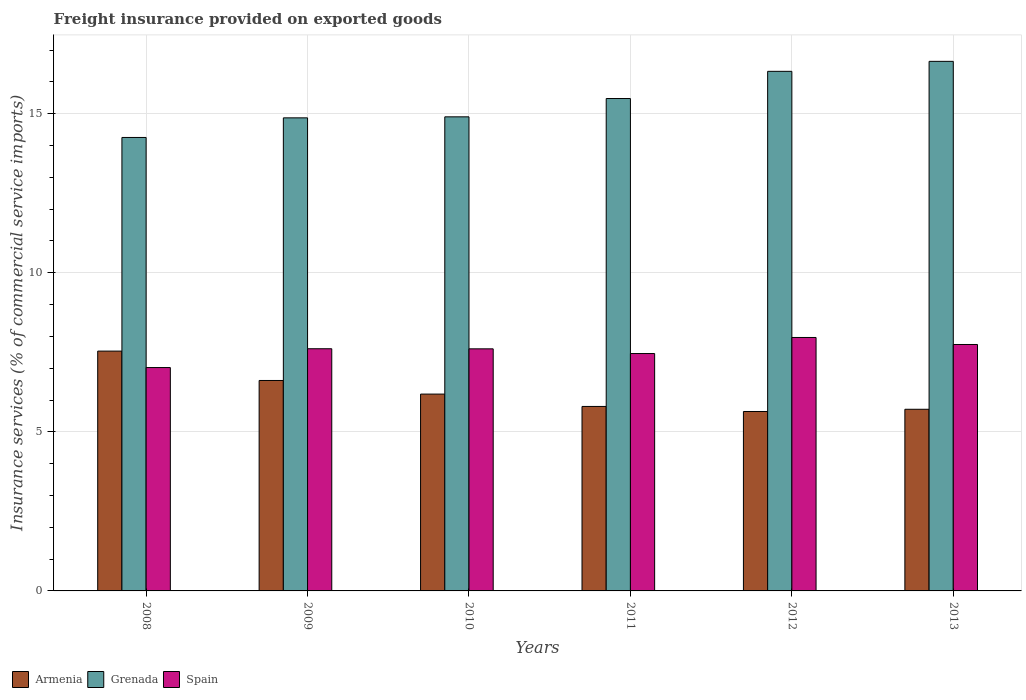How many different coloured bars are there?
Give a very brief answer. 3. Are the number of bars per tick equal to the number of legend labels?
Offer a terse response. Yes. What is the label of the 1st group of bars from the left?
Give a very brief answer. 2008. What is the freight insurance provided on exported goods in Armenia in 2008?
Keep it short and to the point. 7.54. Across all years, what is the maximum freight insurance provided on exported goods in Armenia?
Ensure brevity in your answer.  7.54. Across all years, what is the minimum freight insurance provided on exported goods in Grenada?
Offer a very short reply. 14.25. In which year was the freight insurance provided on exported goods in Spain minimum?
Your answer should be compact. 2008. What is the total freight insurance provided on exported goods in Armenia in the graph?
Offer a very short reply. 37.49. What is the difference between the freight insurance provided on exported goods in Armenia in 2008 and that in 2012?
Provide a short and direct response. 1.9. What is the difference between the freight insurance provided on exported goods in Grenada in 2011 and the freight insurance provided on exported goods in Armenia in 2008?
Your answer should be very brief. 7.94. What is the average freight insurance provided on exported goods in Armenia per year?
Offer a terse response. 6.25. In the year 2011, what is the difference between the freight insurance provided on exported goods in Grenada and freight insurance provided on exported goods in Armenia?
Offer a very short reply. 9.68. In how many years, is the freight insurance provided on exported goods in Armenia greater than 8 %?
Ensure brevity in your answer.  0. What is the ratio of the freight insurance provided on exported goods in Grenada in 2009 to that in 2010?
Provide a short and direct response. 1. Is the freight insurance provided on exported goods in Armenia in 2009 less than that in 2012?
Your response must be concise. No. Is the difference between the freight insurance provided on exported goods in Grenada in 2011 and 2012 greater than the difference between the freight insurance provided on exported goods in Armenia in 2011 and 2012?
Your response must be concise. No. What is the difference between the highest and the second highest freight insurance provided on exported goods in Grenada?
Offer a very short reply. 0.31. What is the difference between the highest and the lowest freight insurance provided on exported goods in Armenia?
Your answer should be very brief. 1.9. In how many years, is the freight insurance provided on exported goods in Spain greater than the average freight insurance provided on exported goods in Spain taken over all years?
Offer a terse response. 4. Is the sum of the freight insurance provided on exported goods in Grenada in 2009 and 2010 greater than the maximum freight insurance provided on exported goods in Armenia across all years?
Offer a terse response. Yes. What does the 2nd bar from the left in 2009 represents?
Give a very brief answer. Grenada. What does the 1st bar from the right in 2012 represents?
Provide a short and direct response. Spain. Are all the bars in the graph horizontal?
Ensure brevity in your answer.  No. What is the difference between two consecutive major ticks on the Y-axis?
Your answer should be compact. 5. Are the values on the major ticks of Y-axis written in scientific E-notation?
Your answer should be very brief. No. Does the graph contain any zero values?
Your answer should be compact. No. Does the graph contain grids?
Offer a terse response. Yes. Where does the legend appear in the graph?
Offer a terse response. Bottom left. How many legend labels are there?
Ensure brevity in your answer.  3. What is the title of the graph?
Make the answer very short. Freight insurance provided on exported goods. Does "Middle East & North Africa (all income levels)" appear as one of the legend labels in the graph?
Ensure brevity in your answer.  No. What is the label or title of the Y-axis?
Your response must be concise. Insurance services (% of commercial service imports). What is the Insurance services (% of commercial service imports) of Armenia in 2008?
Offer a very short reply. 7.54. What is the Insurance services (% of commercial service imports) in Grenada in 2008?
Give a very brief answer. 14.25. What is the Insurance services (% of commercial service imports) in Spain in 2008?
Your response must be concise. 7.02. What is the Insurance services (% of commercial service imports) in Armenia in 2009?
Ensure brevity in your answer.  6.62. What is the Insurance services (% of commercial service imports) in Grenada in 2009?
Your answer should be very brief. 14.87. What is the Insurance services (% of commercial service imports) in Spain in 2009?
Keep it short and to the point. 7.61. What is the Insurance services (% of commercial service imports) of Armenia in 2010?
Offer a very short reply. 6.19. What is the Insurance services (% of commercial service imports) of Grenada in 2010?
Offer a terse response. 14.9. What is the Insurance services (% of commercial service imports) in Spain in 2010?
Ensure brevity in your answer.  7.61. What is the Insurance services (% of commercial service imports) in Armenia in 2011?
Your answer should be compact. 5.8. What is the Insurance services (% of commercial service imports) in Grenada in 2011?
Offer a terse response. 15.48. What is the Insurance services (% of commercial service imports) of Spain in 2011?
Offer a very short reply. 7.46. What is the Insurance services (% of commercial service imports) in Armenia in 2012?
Provide a short and direct response. 5.64. What is the Insurance services (% of commercial service imports) in Grenada in 2012?
Keep it short and to the point. 16.33. What is the Insurance services (% of commercial service imports) of Spain in 2012?
Provide a short and direct response. 7.97. What is the Insurance services (% of commercial service imports) in Armenia in 2013?
Offer a terse response. 5.71. What is the Insurance services (% of commercial service imports) of Grenada in 2013?
Keep it short and to the point. 16.65. What is the Insurance services (% of commercial service imports) in Spain in 2013?
Give a very brief answer. 7.75. Across all years, what is the maximum Insurance services (% of commercial service imports) in Armenia?
Your answer should be very brief. 7.54. Across all years, what is the maximum Insurance services (% of commercial service imports) of Grenada?
Your answer should be very brief. 16.65. Across all years, what is the maximum Insurance services (% of commercial service imports) in Spain?
Give a very brief answer. 7.97. Across all years, what is the minimum Insurance services (% of commercial service imports) in Armenia?
Provide a short and direct response. 5.64. Across all years, what is the minimum Insurance services (% of commercial service imports) of Grenada?
Offer a very short reply. 14.25. Across all years, what is the minimum Insurance services (% of commercial service imports) in Spain?
Your answer should be compact. 7.02. What is the total Insurance services (% of commercial service imports) of Armenia in the graph?
Offer a very short reply. 37.49. What is the total Insurance services (% of commercial service imports) in Grenada in the graph?
Provide a short and direct response. 92.49. What is the total Insurance services (% of commercial service imports) of Spain in the graph?
Give a very brief answer. 45.42. What is the difference between the Insurance services (% of commercial service imports) in Armenia in 2008 and that in 2009?
Make the answer very short. 0.92. What is the difference between the Insurance services (% of commercial service imports) in Grenada in 2008 and that in 2009?
Your answer should be very brief. -0.62. What is the difference between the Insurance services (% of commercial service imports) of Spain in 2008 and that in 2009?
Provide a short and direct response. -0.59. What is the difference between the Insurance services (% of commercial service imports) of Armenia in 2008 and that in 2010?
Offer a terse response. 1.35. What is the difference between the Insurance services (% of commercial service imports) in Grenada in 2008 and that in 2010?
Keep it short and to the point. -0.65. What is the difference between the Insurance services (% of commercial service imports) of Spain in 2008 and that in 2010?
Your answer should be very brief. -0.59. What is the difference between the Insurance services (% of commercial service imports) in Armenia in 2008 and that in 2011?
Your answer should be very brief. 1.74. What is the difference between the Insurance services (% of commercial service imports) in Grenada in 2008 and that in 2011?
Keep it short and to the point. -1.22. What is the difference between the Insurance services (% of commercial service imports) of Spain in 2008 and that in 2011?
Provide a short and direct response. -0.44. What is the difference between the Insurance services (% of commercial service imports) of Armenia in 2008 and that in 2012?
Ensure brevity in your answer.  1.9. What is the difference between the Insurance services (% of commercial service imports) of Grenada in 2008 and that in 2012?
Provide a succinct answer. -2.08. What is the difference between the Insurance services (% of commercial service imports) in Spain in 2008 and that in 2012?
Make the answer very short. -0.95. What is the difference between the Insurance services (% of commercial service imports) in Armenia in 2008 and that in 2013?
Offer a terse response. 1.83. What is the difference between the Insurance services (% of commercial service imports) in Grenada in 2008 and that in 2013?
Offer a very short reply. -2.39. What is the difference between the Insurance services (% of commercial service imports) in Spain in 2008 and that in 2013?
Give a very brief answer. -0.72. What is the difference between the Insurance services (% of commercial service imports) in Armenia in 2009 and that in 2010?
Provide a succinct answer. 0.43. What is the difference between the Insurance services (% of commercial service imports) in Grenada in 2009 and that in 2010?
Your answer should be very brief. -0.03. What is the difference between the Insurance services (% of commercial service imports) in Spain in 2009 and that in 2010?
Make the answer very short. 0. What is the difference between the Insurance services (% of commercial service imports) of Armenia in 2009 and that in 2011?
Provide a short and direct response. 0.82. What is the difference between the Insurance services (% of commercial service imports) in Grenada in 2009 and that in 2011?
Your response must be concise. -0.61. What is the difference between the Insurance services (% of commercial service imports) of Spain in 2009 and that in 2011?
Give a very brief answer. 0.15. What is the difference between the Insurance services (% of commercial service imports) of Grenada in 2009 and that in 2012?
Provide a short and direct response. -1.46. What is the difference between the Insurance services (% of commercial service imports) of Spain in 2009 and that in 2012?
Your answer should be very brief. -0.35. What is the difference between the Insurance services (% of commercial service imports) in Armenia in 2009 and that in 2013?
Keep it short and to the point. 0.91. What is the difference between the Insurance services (% of commercial service imports) in Grenada in 2009 and that in 2013?
Provide a short and direct response. -1.78. What is the difference between the Insurance services (% of commercial service imports) in Spain in 2009 and that in 2013?
Provide a succinct answer. -0.13. What is the difference between the Insurance services (% of commercial service imports) in Armenia in 2010 and that in 2011?
Make the answer very short. 0.39. What is the difference between the Insurance services (% of commercial service imports) in Grenada in 2010 and that in 2011?
Your response must be concise. -0.58. What is the difference between the Insurance services (% of commercial service imports) of Spain in 2010 and that in 2011?
Offer a very short reply. 0.15. What is the difference between the Insurance services (% of commercial service imports) in Armenia in 2010 and that in 2012?
Your response must be concise. 0.55. What is the difference between the Insurance services (% of commercial service imports) in Grenada in 2010 and that in 2012?
Your response must be concise. -1.43. What is the difference between the Insurance services (% of commercial service imports) of Spain in 2010 and that in 2012?
Your answer should be very brief. -0.36. What is the difference between the Insurance services (% of commercial service imports) in Armenia in 2010 and that in 2013?
Offer a very short reply. 0.48. What is the difference between the Insurance services (% of commercial service imports) of Grenada in 2010 and that in 2013?
Give a very brief answer. -1.74. What is the difference between the Insurance services (% of commercial service imports) in Spain in 2010 and that in 2013?
Offer a very short reply. -0.14. What is the difference between the Insurance services (% of commercial service imports) in Armenia in 2011 and that in 2012?
Make the answer very short. 0.16. What is the difference between the Insurance services (% of commercial service imports) in Grenada in 2011 and that in 2012?
Your answer should be very brief. -0.85. What is the difference between the Insurance services (% of commercial service imports) in Spain in 2011 and that in 2012?
Make the answer very short. -0.5. What is the difference between the Insurance services (% of commercial service imports) in Armenia in 2011 and that in 2013?
Give a very brief answer. 0.09. What is the difference between the Insurance services (% of commercial service imports) of Grenada in 2011 and that in 2013?
Give a very brief answer. -1.17. What is the difference between the Insurance services (% of commercial service imports) of Spain in 2011 and that in 2013?
Make the answer very short. -0.28. What is the difference between the Insurance services (% of commercial service imports) of Armenia in 2012 and that in 2013?
Your answer should be very brief. -0.07. What is the difference between the Insurance services (% of commercial service imports) of Grenada in 2012 and that in 2013?
Ensure brevity in your answer.  -0.31. What is the difference between the Insurance services (% of commercial service imports) of Spain in 2012 and that in 2013?
Your response must be concise. 0.22. What is the difference between the Insurance services (% of commercial service imports) in Armenia in 2008 and the Insurance services (% of commercial service imports) in Grenada in 2009?
Your response must be concise. -7.33. What is the difference between the Insurance services (% of commercial service imports) in Armenia in 2008 and the Insurance services (% of commercial service imports) in Spain in 2009?
Provide a short and direct response. -0.07. What is the difference between the Insurance services (% of commercial service imports) of Grenada in 2008 and the Insurance services (% of commercial service imports) of Spain in 2009?
Give a very brief answer. 6.64. What is the difference between the Insurance services (% of commercial service imports) of Armenia in 2008 and the Insurance services (% of commercial service imports) of Grenada in 2010?
Your response must be concise. -7.36. What is the difference between the Insurance services (% of commercial service imports) in Armenia in 2008 and the Insurance services (% of commercial service imports) in Spain in 2010?
Your answer should be very brief. -0.07. What is the difference between the Insurance services (% of commercial service imports) in Grenada in 2008 and the Insurance services (% of commercial service imports) in Spain in 2010?
Your answer should be very brief. 6.64. What is the difference between the Insurance services (% of commercial service imports) of Armenia in 2008 and the Insurance services (% of commercial service imports) of Grenada in 2011?
Your answer should be compact. -7.94. What is the difference between the Insurance services (% of commercial service imports) of Armenia in 2008 and the Insurance services (% of commercial service imports) of Spain in 2011?
Offer a terse response. 0.08. What is the difference between the Insurance services (% of commercial service imports) of Grenada in 2008 and the Insurance services (% of commercial service imports) of Spain in 2011?
Provide a succinct answer. 6.79. What is the difference between the Insurance services (% of commercial service imports) of Armenia in 2008 and the Insurance services (% of commercial service imports) of Grenada in 2012?
Offer a very short reply. -8.79. What is the difference between the Insurance services (% of commercial service imports) in Armenia in 2008 and the Insurance services (% of commercial service imports) in Spain in 2012?
Your response must be concise. -0.43. What is the difference between the Insurance services (% of commercial service imports) of Grenada in 2008 and the Insurance services (% of commercial service imports) of Spain in 2012?
Ensure brevity in your answer.  6.29. What is the difference between the Insurance services (% of commercial service imports) of Armenia in 2008 and the Insurance services (% of commercial service imports) of Grenada in 2013?
Your answer should be compact. -9.11. What is the difference between the Insurance services (% of commercial service imports) in Armenia in 2008 and the Insurance services (% of commercial service imports) in Spain in 2013?
Your answer should be compact. -0.21. What is the difference between the Insurance services (% of commercial service imports) of Grenada in 2008 and the Insurance services (% of commercial service imports) of Spain in 2013?
Offer a terse response. 6.51. What is the difference between the Insurance services (% of commercial service imports) of Armenia in 2009 and the Insurance services (% of commercial service imports) of Grenada in 2010?
Your response must be concise. -8.29. What is the difference between the Insurance services (% of commercial service imports) in Armenia in 2009 and the Insurance services (% of commercial service imports) in Spain in 2010?
Provide a succinct answer. -0.99. What is the difference between the Insurance services (% of commercial service imports) in Grenada in 2009 and the Insurance services (% of commercial service imports) in Spain in 2010?
Keep it short and to the point. 7.26. What is the difference between the Insurance services (% of commercial service imports) of Armenia in 2009 and the Insurance services (% of commercial service imports) of Grenada in 2011?
Your answer should be very brief. -8.86. What is the difference between the Insurance services (% of commercial service imports) of Armenia in 2009 and the Insurance services (% of commercial service imports) of Spain in 2011?
Provide a succinct answer. -0.85. What is the difference between the Insurance services (% of commercial service imports) in Grenada in 2009 and the Insurance services (% of commercial service imports) in Spain in 2011?
Offer a terse response. 7.41. What is the difference between the Insurance services (% of commercial service imports) in Armenia in 2009 and the Insurance services (% of commercial service imports) in Grenada in 2012?
Offer a terse response. -9.72. What is the difference between the Insurance services (% of commercial service imports) in Armenia in 2009 and the Insurance services (% of commercial service imports) in Spain in 2012?
Offer a very short reply. -1.35. What is the difference between the Insurance services (% of commercial service imports) of Grenada in 2009 and the Insurance services (% of commercial service imports) of Spain in 2012?
Provide a short and direct response. 6.9. What is the difference between the Insurance services (% of commercial service imports) in Armenia in 2009 and the Insurance services (% of commercial service imports) in Grenada in 2013?
Keep it short and to the point. -10.03. What is the difference between the Insurance services (% of commercial service imports) of Armenia in 2009 and the Insurance services (% of commercial service imports) of Spain in 2013?
Provide a succinct answer. -1.13. What is the difference between the Insurance services (% of commercial service imports) of Grenada in 2009 and the Insurance services (% of commercial service imports) of Spain in 2013?
Your response must be concise. 7.12. What is the difference between the Insurance services (% of commercial service imports) in Armenia in 2010 and the Insurance services (% of commercial service imports) in Grenada in 2011?
Provide a succinct answer. -9.29. What is the difference between the Insurance services (% of commercial service imports) in Armenia in 2010 and the Insurance services (% of commercial service imports) in Spain in 2011?
Offer a very short reply. -1.27. What is the difference between the Insurance services (% of commercial service imports) in Grenada in 2010 and the Insurance services (% of commercial service imports) in Spain in 2011?
Your answer should be very brief. 7.44. What is the difference between the Insurance services (% of commercial service imports) of Armenia in 2010 and the Insurance services (% of commercial service imports) of Grenada in 2012?
Give a very brief answer. -10.15. What is the difference between the Insurance services (% of commercial service imports) of Armenia in 2010 and the Insurance services (% of commercial service imports) of Spain in 2012?
Provide a succinct answer. -1.78. What is the difference between the Insurance services (% of commercial service imports) of Grenada in 2010 and the Insurance services (% of commercial service imports) of Spain in 2012?
Provide a short and direct response. 6.94. What is the difference between the Insurance services (% of commercial service imports) in Armenia in 2010 and the Insurance services (% of commercial service imports) in Grenada in 2013?
Offer a terse response. -10.46. What is the difference between the Insurance services (% of commercial service imports) of Armenia in 2010 and the Insurance services (% of commercial service imports) of Spain in 2013?
Ensure brevity in your answer.  -1.56. What is the difference between the Insurance services (% of commercial service imports) in Grenada in 2010 and the Insurance services (% of commercial service imports) in Spain in 2013?
Offer a very short reply. 7.16. What is the difference between the Insurance services (% of commercial service imports) of Armenia in 2011 and the Insurance services (% of commercial service imports) of Grenada in 2012?
Provide a short and direct response. -10.53. What is the difference between the Insurance services (% of commercial service imports) of Armenia in 2011 and the Insurance services (% of commercial service imports) of Spain in 2012?
Offer a terse response. -2.17. What is the difference between the Insurance services (% of commercial service imports) in Grenada in 2011 and the Insurance services (% of commercial service imports) in Spain in 2012?
Ensure brevity in your answer.  7.51. What is the difference between the Insurance services (% of commercial service imports) in Armenia in 2011 and the Insurance services (% of commercial service imports) in Grenada in 2013?
Give a very brief answer. -10.85. What is the difference between the Insurance services (% of commercial service imports) of Armenia in 2011 and the Insurance services (% of commercial service imports) of Spain in 2013?
Give a very brief answer. -1.95. What is the difference between the Insurance services (% of commercial service imports) of Grenada in 2011 and the Insurance services (% of commercial service imports) of Spain in 2013?
Keep it short and to the point. 7.73. What is the difference between the Insurance services (% of commercial service imports) in Armenia in 2012 and the Insurance services (% of commercial service imports) in Grenada in 2013?
Provide a succinct answer. -11.01. What is the difference between the Insurance services (% of commercial service imports) of Armenia in 2012 and the Insurance services (% of commercial service imports) of Spain in 2013?
Provide a short and direct response. -2.11. What is the difference between the Insurance services (% of commercial service imports) of Grenada in 2012 and the Insurance services (% of commercial service imports) of Spain in 2013?
Provide a short and direct response. 8.59. What is the average Insurance services (% of commercial service imports) of Armenia per year?
Provide a short and direct response. 6.25. What is the average Insurance services (% of commercial service imports) of Grenada per year?
Give a very brief answer. 15.41. What is the average Insurance services (% of commercial service imports) of Spain per year?
Provide a succinct answer. 7.57. In the year 2008, what is the difference between the Insurance services (% of commercial service imports) in Armenia and Insurance services (% of commercial service imports) in Grenada?
Make the answer very short. -6.72. In the year 2008, what is the difference between the Insurance services (% of commercial service imports) in Armenia and Insurance services (% of commercial service imports) in Spain?
Provide a succinct answer. 0.52. In the year 2008, what is the difference between the Insurance services (% of commercial service imports) of Grenada and Insurance services (% of commercial service imports) of Spain?
Your answer should be very brief. 7.23. In the year 2009, what is the difference between the Insurance services (% of commercial service imports) of Armenia and Insurance services (% of commercial service imports) of Grenada?
Your answer should be very brief. -8.26. In the year 2009, what is the difference between the Insurance services (% of commercial service imports) of Armenia and Insurance services (% of commercial service imports) of Spain?
Ensure brevity in your answer.  -1. In the year 2009, what is the difference between the Insurance services (% of commercial service imports) of Grenada and Insurance services (% of commercial service imports) of Spain?
Provide a succinct answer. 7.26. In the year 2010, what is the difference between the Insurance services (% of commercial service imports) in Armenia and Insurance services (% of commercial service imports) in Grenada?
Make the answer very short. -8.72. In the year 2010, what is the difference between the Insurance services (% of commercial service imports) of Armenia and Insurance services (% of commercial service imports) of Spain?
Ensure brevity in your answer.  -1.42. In the year 2010, what is the difference between the Insurance services (% of commercial service imports) of Grenada and Insurance services (% of commercial service imports) of Spain?
Offer a terse response. 7.29. In the year 2011, what is the difference between the Insurance services (% of commercial service imports) of Armenia and Insurance services (% of commercial service imports) of Grenada?
Ensure brevity in your answer.  -9.68. In the year 2011, what is the difference between the Insurance services (% of commercial service imports) of Armenia and Insurance services (% of commercial service imports) of Spain?
Offer a terse response. -1.66. In the year 2011, what is the difference between the Insurance services (% of commercial service imports) of Grenada and Insurance services (% of commercial service imports) of Spain?
Provide a short and direct response. 8.02. In the year 2012, what is the difference between the Insurance services (% of commercial service imports) of Armenia and Insurance services (% of commercial service imports) of Grenada?
Ensure brevity in your answer.  -10.69. In the year 2012, what is the difference between the Insurance services (% of commercial service imports) in Armenia and Insurance services (% of commercial service imports) in Spain?
Offer a very short reply. -2.33. In the year 2012, what is the difference between the Insurance services (% of commercial service imports) in Grenada and Insurance services (% of commercial service imports) in Spain?
Your answer should be compact. 8.37. In the year 2013, what is the difference between the Insurance services (% of commercial service imports) of Armenia and Insurance services (% of commercial service imports) of Grenada?
Offer a very short reply. -10.94. In the year 2013, what is the difference between the Insurance services (% of commercial service imports) in Armenia and Insurance services (% of commercial service imports) in Spain?
Offer a terse response. -2.04. In the year 2013, what is the difference between the Insurance services (% of commercial service imports) of Grenada and Insurance services (% of commercial service imports) of Spain?
Offer a terse response. 8.9. What is the ratio of the Insurance services (% of commercial service imports) in Armenia in 2008 to that in 2009?
Provide a succinct answer. 1.14. What is the ratio of the Insurance services (% of commercial service imports) in Grenada in 2008 to that in 2009?
Provide a short and direct response. 0.96. What is the ratio of the Insurance services (% of commercial service imports) in Spain in 2008 to that in 2009?
Offer a terse response. 0.92. What is the ratio of the Insurance services (% of commercial service imports) in Armenia in 2008 to that in 2010?
Make the answer very short. 1.22. What is the ratio of the Insurance services (% of commercial service imports) in Grenada in 2008 to that in 2010?
Your answer should be compact. 0.96. What is the ratio of the Insurance services (% of commercial service imports) of Spain in 2008 to that in 2010?
Offer a very short reply. 0.92. What is the ratio of the Insurance services (% of commercial service imports) of Armenia in 2008 to that in 2011?
Provide a short and direct response. 1.3. What is the ratio of the Insurance services (% of commercial service imports) of Grenada in 2008 to that in 2011?
Your answer should be very brief. 0.92. What is the ratio of the Insurance services (% of commercial service imports) of Spain in 2008 to that in 2011?
Your answer should be very brief. 0.94. What is the ratio of the Insurance services (% of commercial service imports) of Armenia in 2008 to that in 2012?
Give a very brief answer. 1.34. What is the ratio of the Insurance services (% of commercial service imports) of Grenada in 2008 to that in 2012?
Give a very brief answer. 0.87. What is the ratio of the Insurance services (% of commercial service imports) of Spain in 2008 to that in 2012?
Your answer should be compact. 0.88. What is the ratio of the Insurance services (% of commercial service imports) of Armenia in 2008 to that in 2013?
Ensure brevity in your answer.  1.32. What is the ratio of the Insurance services (% of commercial service imports) of Grenada in 2008 to that in 2013?
Offer a terse response. 0.86. What is the ratio of the Insurance services (% of commercial service imports) of Spain in 2008 to that in 2013?
Give a very brief answer. 0.91. What is the ratio of the Insurance services (% of commercial service imports) in Armenia in 2009 to that in 2010?
Keep it short and to the point. 1.07. What is the ratio of the Insurance services (% of commercial service imports) of Spain in 2009 to that in 2010?
Provide a short and direct response. 1. What is the ratio of the Insurance services (% of commercial service imports) of Armenia in 2009 to that in 2011?
Your answer should be compact. 1.14. What is the ratio of the Insurance services (% of commercial service imports) in Grenada in 2009 to that in 2011?
Make the answer very short. 0.96. What is the ratio of the Insurance services (% of commercial service imports) of Spain in 2009 to that in 2011?
Keep it short and to the point. 1.02. What is the ratio of the Insurance services (% of commercial service imports) of Armenia in 2009 to that in 2012?
Your response must be concise. 1.17. What is the ratio of the Insurance services (% of commercial service imports) in Grenada in 2009 to that in 2012?
Ensure brevity in your answer.  0.91. What is the ratio of the Insurance services (% of commercial service imports) of Spain in 2009 to that in 2012?
Offer a terse response. 0.96. What is the ratio of the Insurance services (% of commercial service imports) in Armenia in 2009 to that in 2013?
Ensure brevity in your answer.  1.16. What is the ratio of the Insurance services (% of commercial service imports) in Grenada in 2009 to that in 2013?
Ensure brevity in your answer.  0.89. What is the ratio of the Insurance services (% of commercial service imports) of Spain in 2009 to that in 2013?
Offer a very short reply. 0.98. What is the ratio of the Insurance services (% of commercial service imports) of Armenia in 2010 to that in 2011?
Provide a succinct answer. 1.07. What is the ratio of the Insurance services (% of commercial service imports) of Grenada in 2010 to that in 2011?
Your answer should be compact. 0.96. What is the ratio of the Insurance services (% of commercial service imports) in Spain in 2010 to that in 2011?
Your answer should be compact. 1.02. What is the ratio of the Insurance services (% of commercial service imports) of Armenia in 2010 to that in 2012?
Keep it short and to the point. 1.1. What is the ratio of the Insurance services (% of commercial service imports) of Grenada in 2010 to that in 2012?
Your answer should be very brief. 0.91. What is the ratio of the Insurance services (% of commercial service imports) of Spain in 2010 to that in 2012?
Your response must be concise. 0.96. What is the ratio of the Insurance services (% of commercial service imports) of Armenia in 2010 to that in 2013?
Offer a terse response. 1.08. What is the ratio of the Insurance services (% of commercial service imports) in Grenada in 2010 to that in 2013?
Keep it short and to the point. 0.9. What is the ratio of the Insurance services (% of commercial service imports) of Spain in 2010 to that in 2013?
Your answer should be compact. 0.98. What is the ratio of the Insurance services (% of commercial service imports) in Armenia in 2011 to that in 2012?
Offer a very short reply. 1.03. What is the ratio of the Insurance services (% of commercial service imports) in Grenada in 2011 to that in 2012?
Make the answer very short. 0.95. What is the ratio of the Insurance services (% of commercial service imports) of Spain in 2011 to that in 2012?
Your answer should be compact. 0.94. What is the ratio of the Insurance services (% of commercial service imports) in Armenia in 2011 to that in 2013?
Keep it short and to the point. 1.02. What is the ratio of the Insurance services (% of commercial service imports) in Grenada in 2011 to that in 2013?
Provide a succinct answer. 0.93. What is the ratio of the Insurance services (% of commercial service imports) of Spain in 2011 to that in 2013?
Keep it short and to the point. 0.96. What is the ratio of the Insurance services (% of commercial service imports) of Grenada in 2012 to that in 2013?
Offer a very short reply. 0.98. What is the ratio of the Insurance services (% of commercial service imports) of Spain in 2012 to that in 2013?
Your answer should be compact. 1.03. What is the difference between the highest and the second highest Insurance services (% of commercial service imports) in Armenia?
Provide a short and direct response. 0.92. What is the difference between the highest and the second highest Insurance services (% of commercial service imports) in Grenada?
Give a very brief answer. 0.31. What is the difference between the highest and the second highest Insurance services (% of commercial service imports) of Spain?
Offer a terse response. 0.22. What is the difference between the highest and the lowest Insurance services (% of commercial service imports) of Armenia?
Offer a very short reply. 1.9. What is the difference between the highest and the lowest Insurance services (% of commercial service imports) in Grenada?
Keep it short and to the point. 2.39. What is the difference between the highest and the lowest Insurance services (% of commercial service imports) of Spain?
Give a very brief answer. 0.95. 